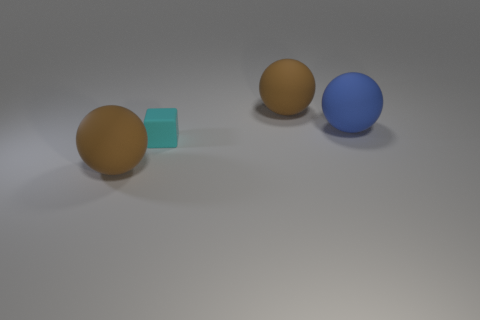Add 2 small cyan cubes. How many small cyan cubes exist? 3 Add 2 big spheres. How many objects exist? 6 Subtract all brown balls. How many balls are left? 1 Subtract all big blue balls. How many balls are left? 2 Subtract 0 gray cylinders. How many objects are left? 4 Subtract all spheres. How many objects are left? 1 Subtract 1 spheres. How many spheres are left? 2 Subtract all yellow cubes. Subtract all gray spheres. How many cubes are left? 1 Subtract all yellow blocks. How many brown spheres are left? 2 Subtract all tiny red metallic cubes. Subtract all blocks. How many objects are left? 3 